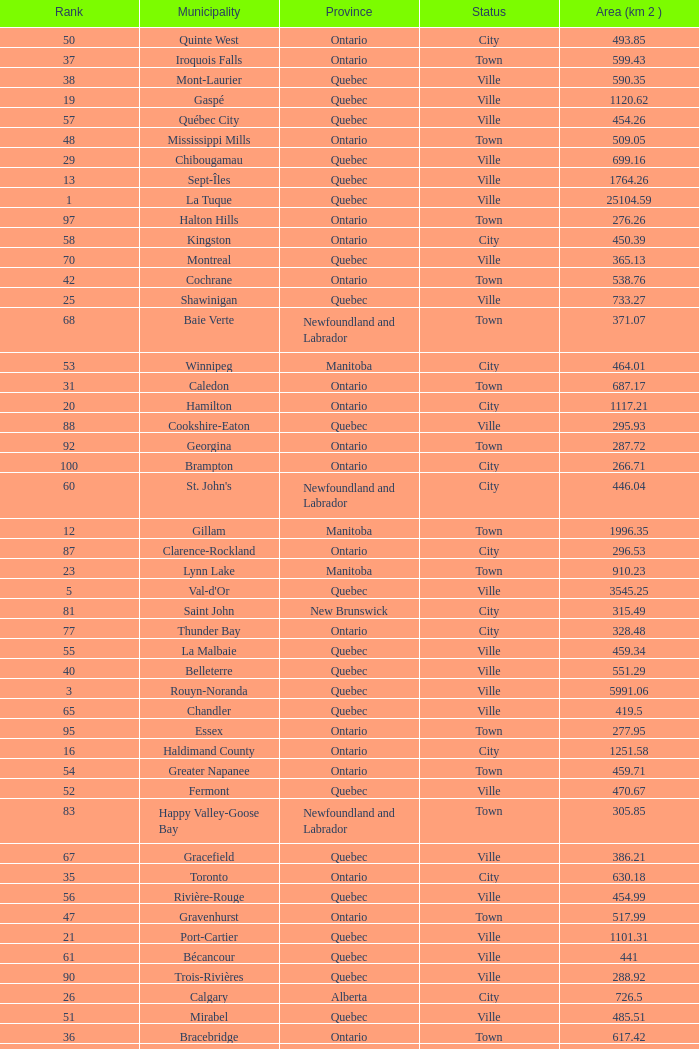What is the listed Status that has the Province of Ontario and Rank of 86? Town. 